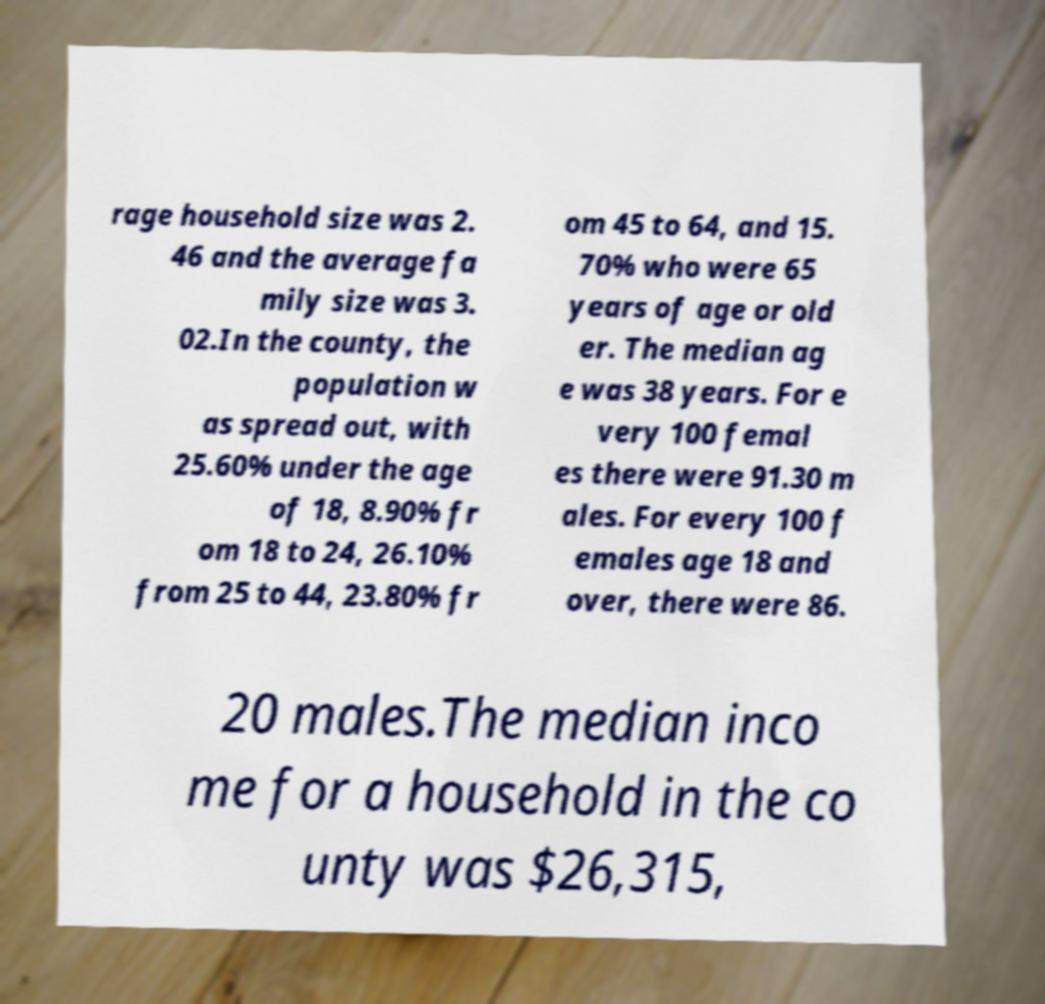Could you extract and type out the text from this image? rage household size was 2. 46 and the average fa mily size was 3. 02.In the county, the population w as spread out, with 25.60% under the age of 18, 8.90% fr om 18 to 24, 26.10% from 25 to 44, 23.80% fr om 45 to 64, and 15. 70% who were 65 years of age or old er. The median ag e was 38 years. For e very 100 femal es there were 91.30 m ales. For every 100 f emales age 18 and over, there were 86. 20 males.The median inco me for a household in the co unty was $26,315, 